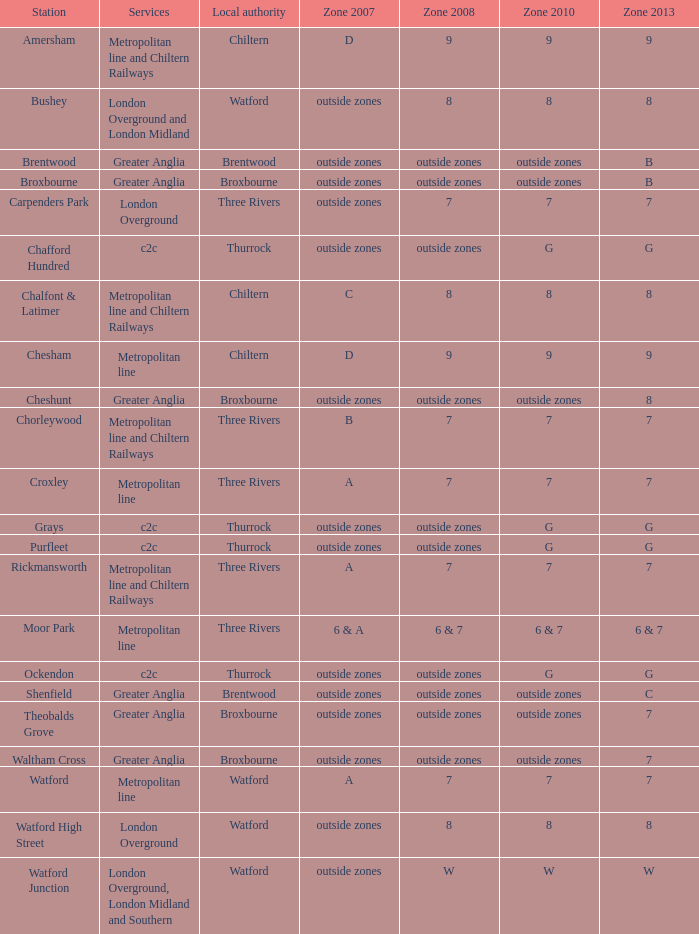Which part of zone 2008 includes both greater anglia services and a station in cheshunt? Outside zones. 